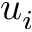Convert formula to latex. <formula><loc_0><loc_0><loc_500><loc_500>u _ { i }</formula> 